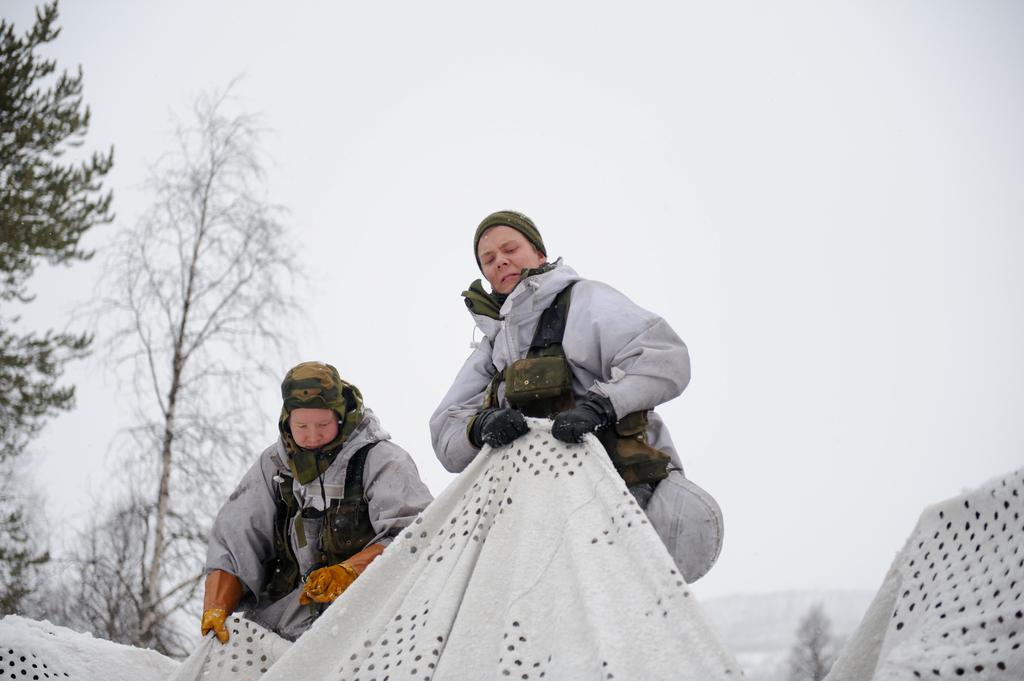Can you describe this image briefly? In this image we can see two persons wearing hand gloves and holding the same cloth. In the background we can see the trees and also the sky. 